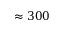Convert formula to latex. <formula><loc_0><loc_0><loc_500><loc_500>\approx 3 0 0</formula> 